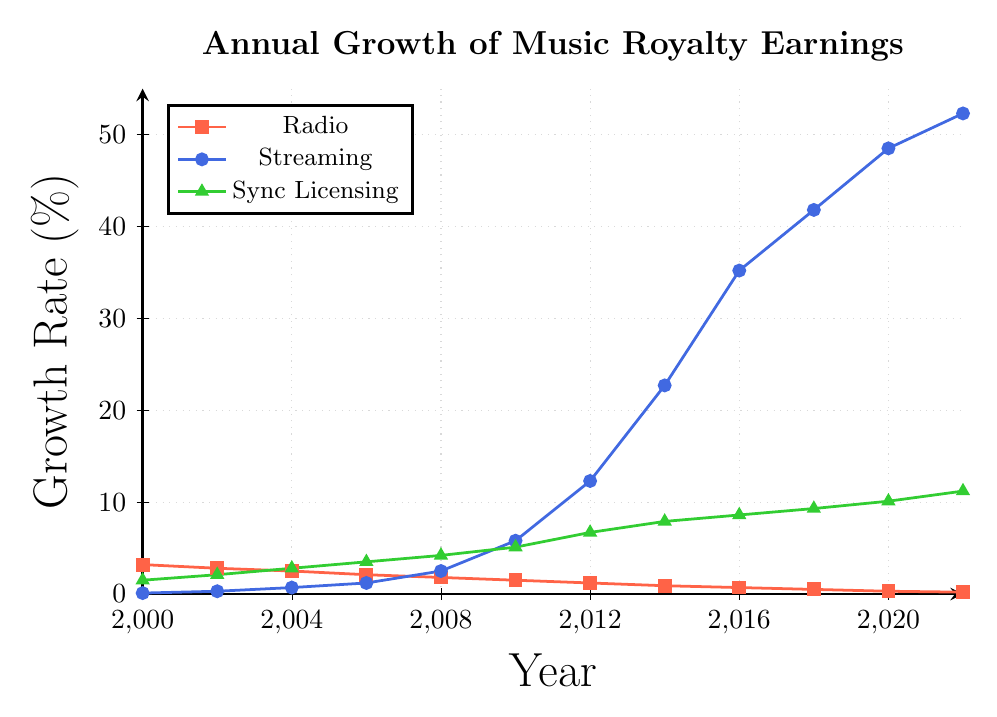What is the growth rate for radio royalties in 2022? Look at the plotted data point for radio royalties at the year 2022.
Answer: 0.2% How did the growth rate of streaming royalties change from 2000 to 2022? Compare the data points for streaming royalties between the year 2000 and 2022.
Answer: Increased from 0.1% to 52.3% Which royalty source had the highest growth rate in 2010? Compare the plotted data points for radio, streaming, and sync licensing royalties in the year 2010.
Answer: Streaming By how much did the growth rate of sync licensing royalties increase from 2006 to 2022? Subtract the growth rate of sync licensing royalties in 2006 from the growth rate in 2022 (11.2% - 3.5%).
Answer: 7.7% Compare the growth rates of radio and streaming royalties in 2016. Which was higher and by how much? Compare the growth rates for radio and streaming in 2016 (35.2% for streaming and 0.7% for radio). Subtract the radio growth rate from the streaming growth rate (35.2% - 0.7%).
Answer: Streaming, by 34.5% What is the trend of radio royalties growth rate from 2000 to 2022? Observe the plotted data points for radio royalties from 2000 to 2022. Describe the overall pattern observed.
Answer: Steady decline What was the approximate difference in growth rates between radio and sync licensing royalties in 2008? Subtract the growth rate of radio royalties from the growth rate of sync licensing royalties in 2008 (4.2% - 1.8%).
Answer: 2.4% In which year did streaming royalties see the largest single-year growth between 2000 and 2022? Observe the plotted data points for streaming royalties and identify the year with the steepest upward jump.
Answer: 2012 What is the overall trend for sync licensing royalties from 2000 to 2022? Observe the plotted data points for sync licensing royalties from 2000 to 2022. Describe the overall pattern observed.
Answer: Steady increase How much did the growth rate of streaming royalties increase between 2004 and 2014? Subtract the growth rate of streaming royalties in 2004 from the growth rate in 2014 (22.7% - 0.7%).
Answer: 22% 